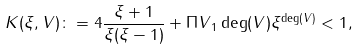Convert formula to latex. <formula><loc_0><loc_0><loc_500><loc_500>K ( \xi , V ) \colon = 4 \frac { \xi + 1 } { \xi ( \xi - 1 ) } + \| \Pi V \| _ { 1 } \deg ( V ) \xi ^ { \deg ( V ) } < 1 ,</formula> 